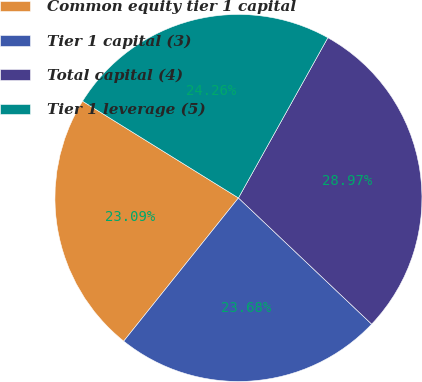Convert chart to OTSL. <chart><loc_0><loc_0><loc_500><loc_500><pie_chart><fcel>Common equity tier 1 capital<fcel>Tier 1 capital (3)<fcel>Total capital (4)<fcel>Tier 1 leverage (5)<nl><fcel>23.09%<fcel>23.68%<fcel>28.97%<fcel>24.26%<nl></chart> 